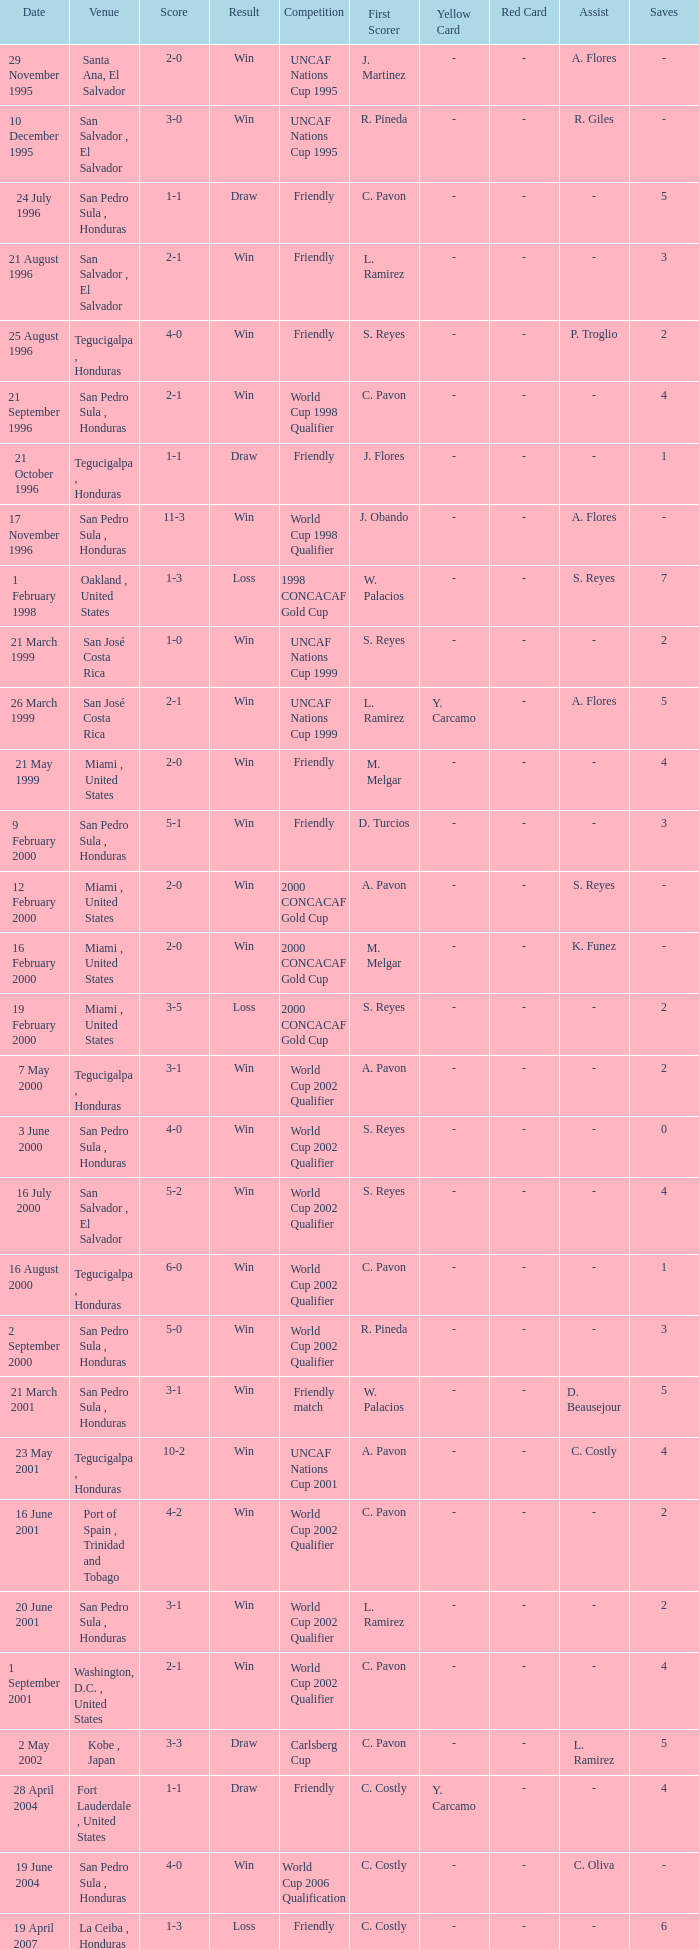What is the venue for the friendly competition and score of 4-0? Tegucigalpa , Honduras. 